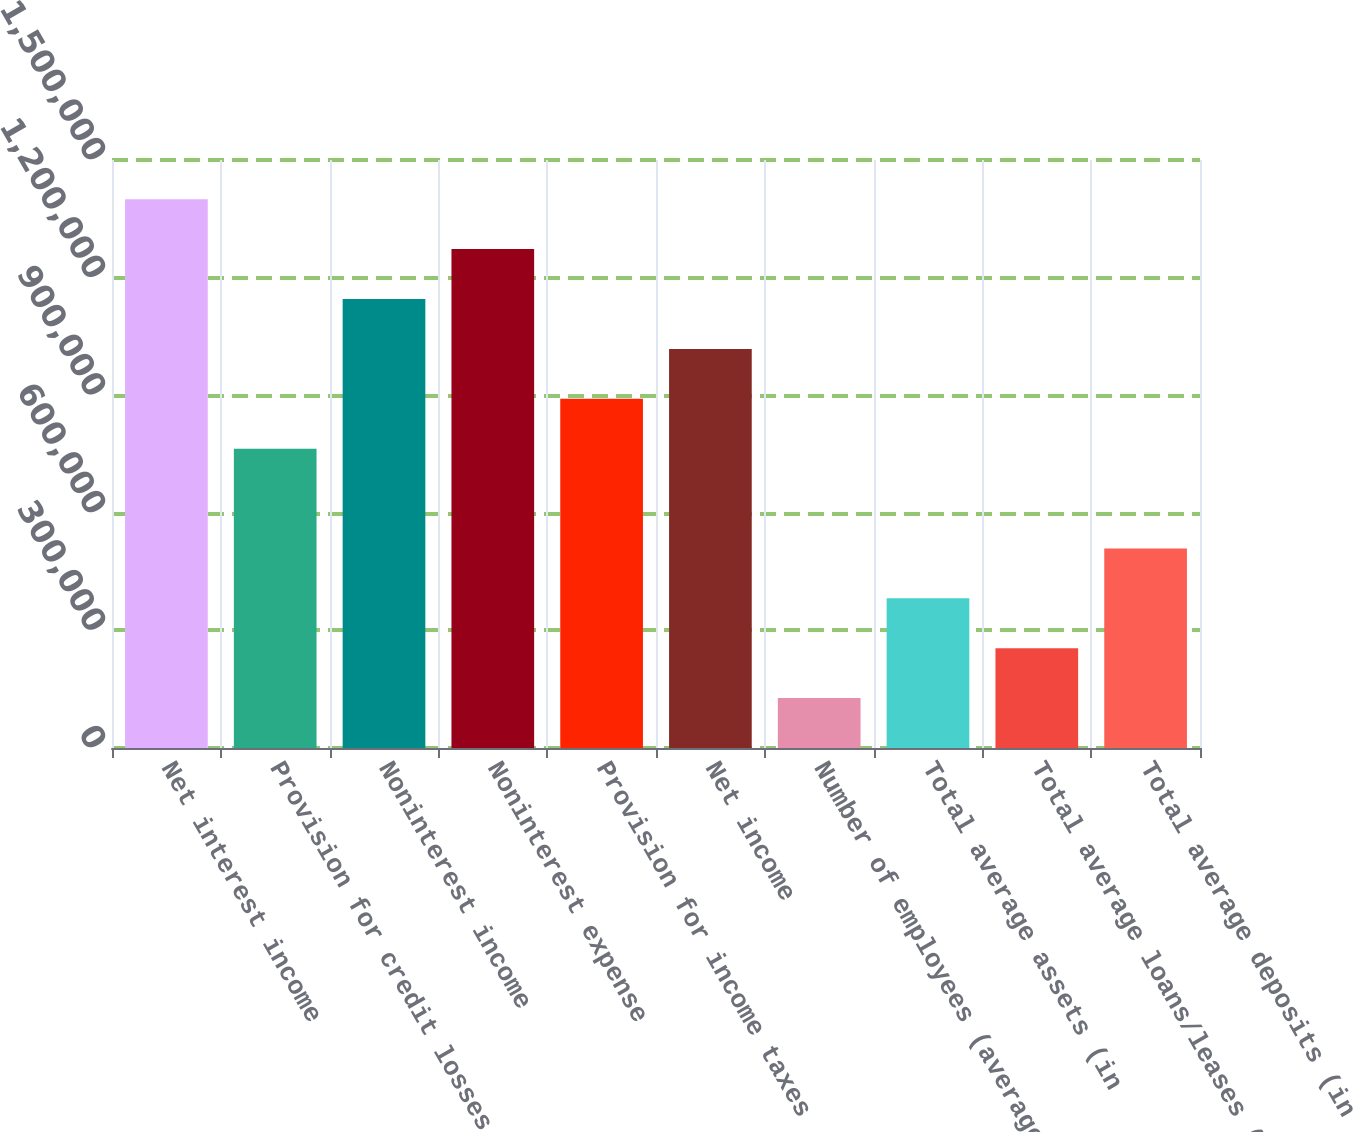Convert chart. <chart><loc_0><loc_0><loc_500><loc_500><bar_chart><fcel>Net interest income<fcel>Provision for credit losses<fcel>Noninterest income<fcel>Noninterest expense<fcel>Provision for income taxes<fcel>Net income<fcel>Number of employees (average<fcel>Total average assets (in<fcel>Total average loans/leases (in<fcel>Total average deposits (in<nl><fcel>1.39998e+06<fcel>763629<fcel>1.14544e+06<fcel>1.27271e+06<fcel>890900<fcel>1.01817e+06<fcel>127275<fcel>381816<fcel>254545<fcel>509087<nl></chart> 